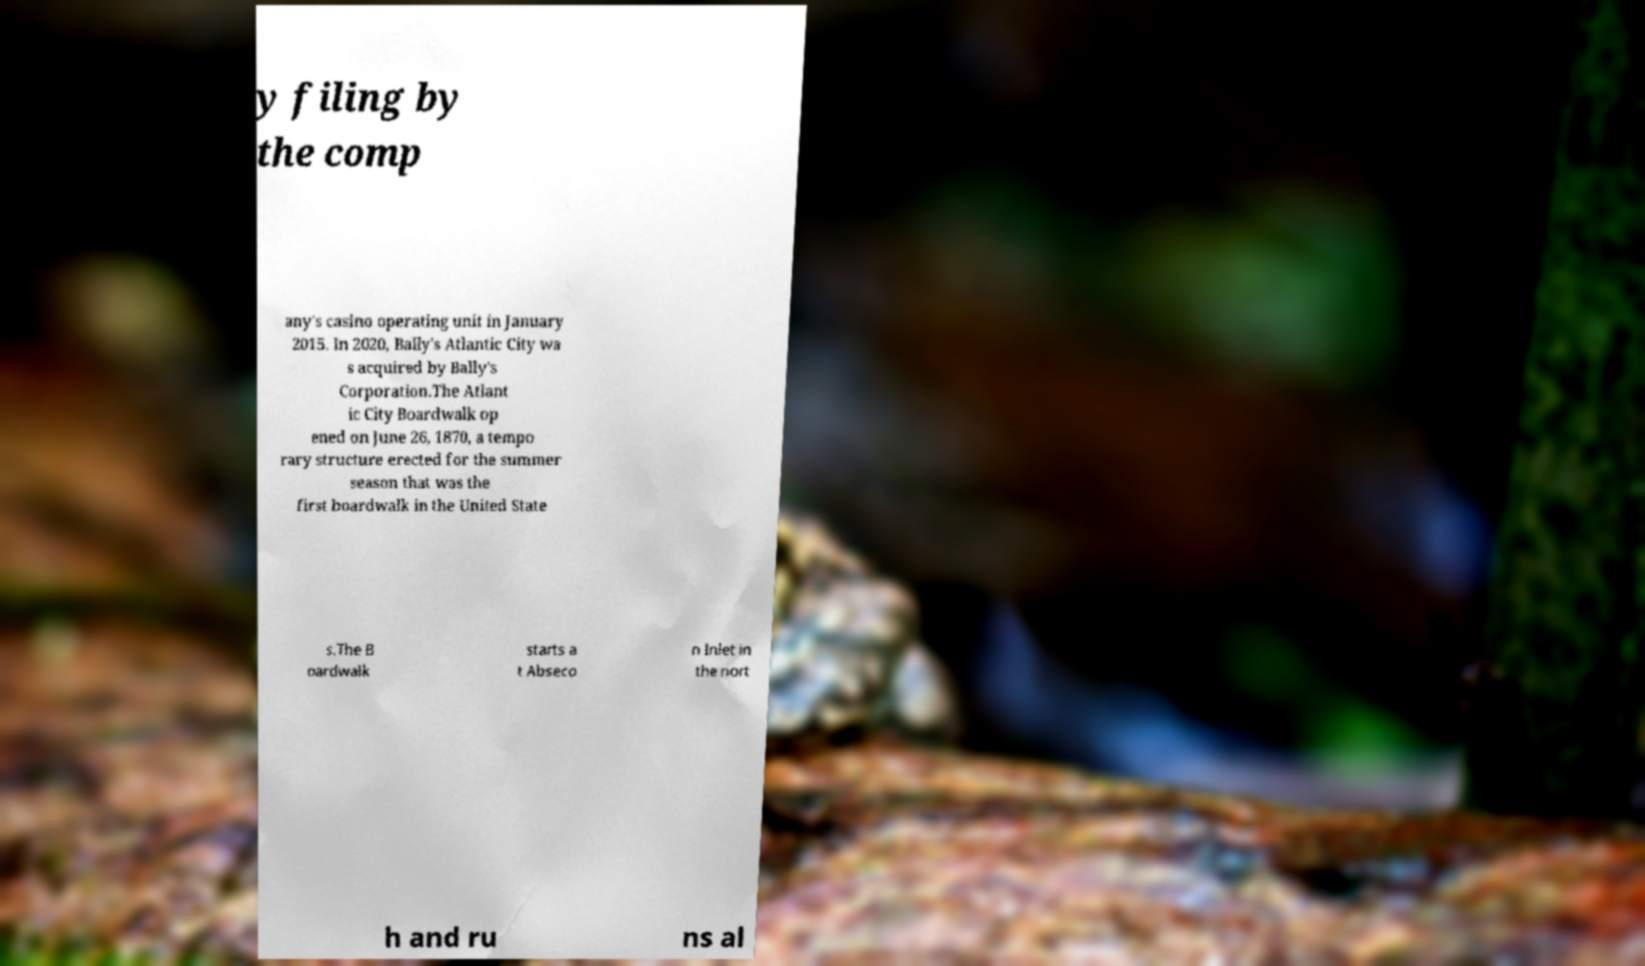Could you assist in decoding the text presented in this image and type it out clearly? y filing by the comp any's casino operating unit in January 2015. In 2020, Bally's Atlantic City wa s acquired by Bally's Corporation.The Atlant ic City Boardwalk op ened on June 26, 1870, a tempo rary structure erected for the summer season that was the first boardwalk in the United State s.The B oardwalk starts a t Abseco n Inlet in the nort h and ru ns al 